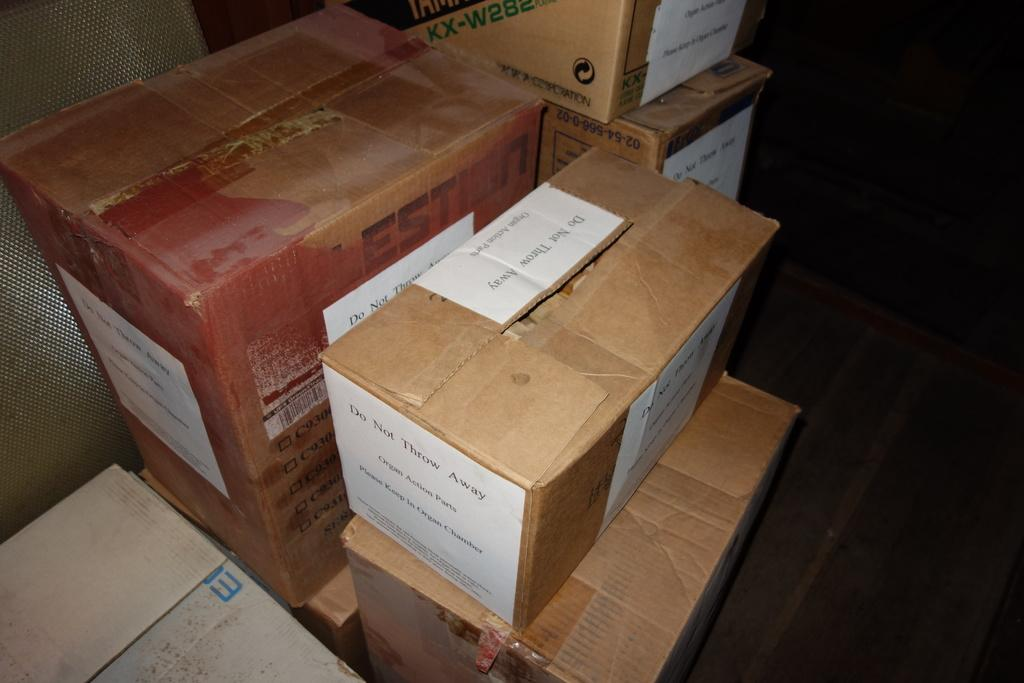<image>
Create a compact narrative representing the image presented. The box contains Organ Action Parts and to please keep in organ chamber. 